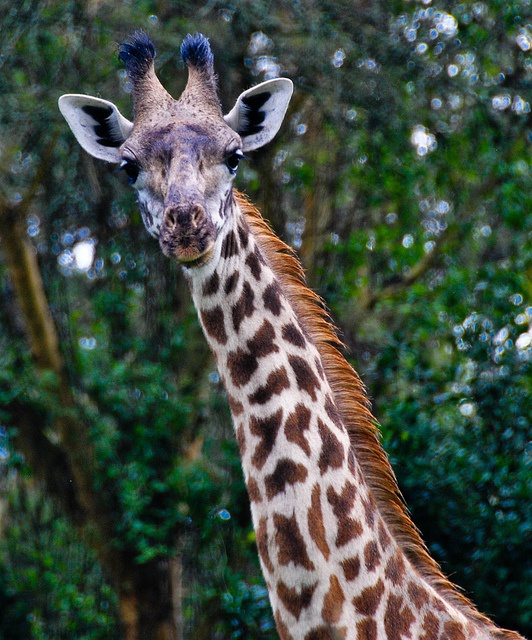Describe the objects in this image and their specific colors. I can see a giraffe in purple, black, darkgray, gray, and lightgray tones in this image. 